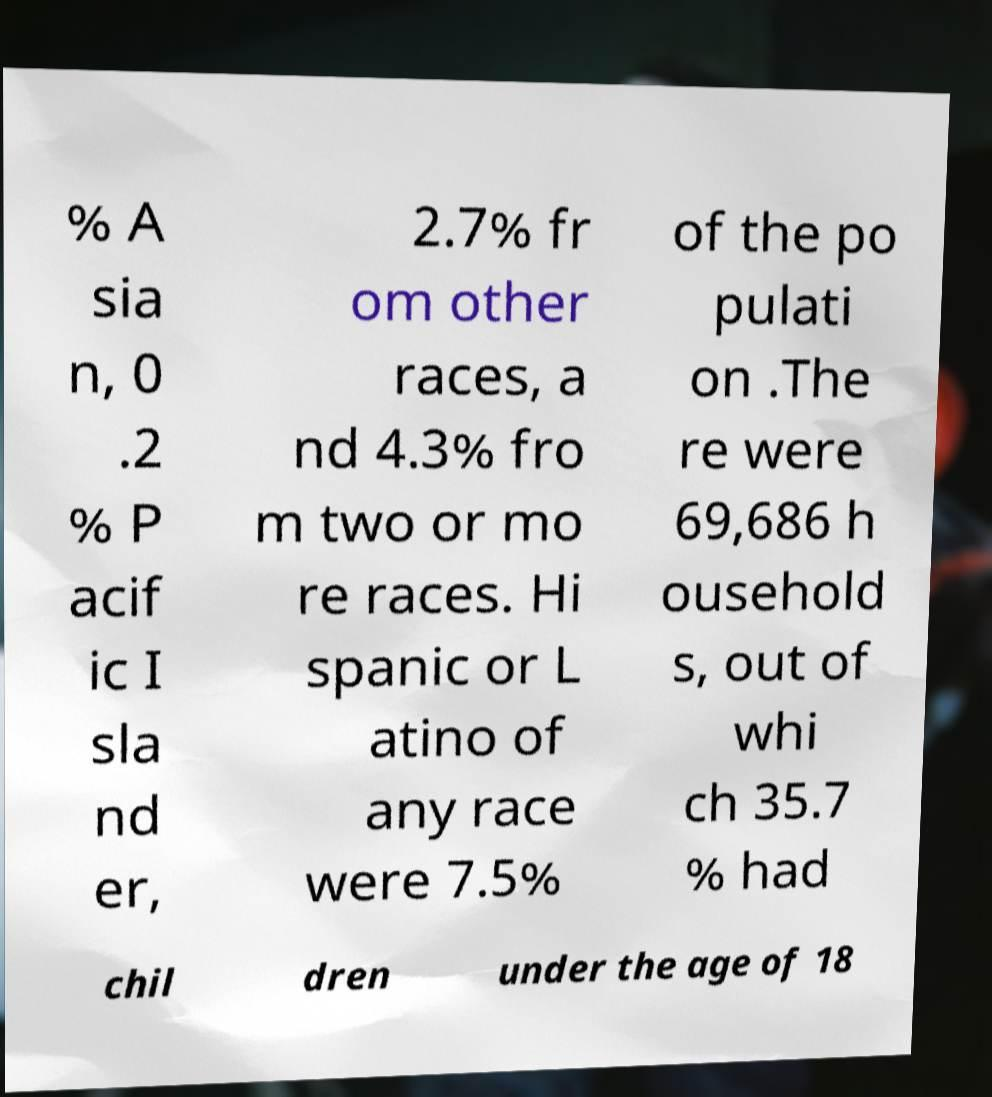Can you read and provide the text displayed in the image?This photo seems to have some interesting text. Can you extract and type it out for me? % A sia n, 0 .2 % P acif ic I sla nd er, 2.7% fr om other races, a nd 4.3% fro m two or mo re races. Hi spanic or L atino of any race were 7.5% of the po pulati on .The re were 69,686 h ousehold s, out of whi ch 35.7 % had chil dren under the age of 18 